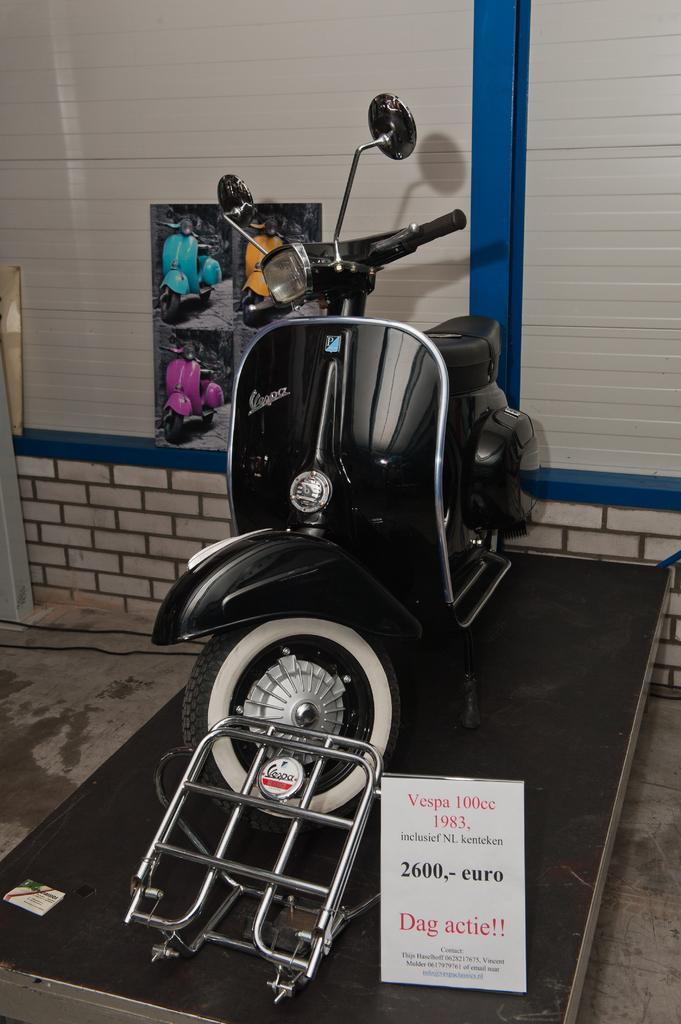Describe this image in one or two sentences. Here I can see a bike is placed on a metal surface. Along with the bike there are some metal rods and a board. On the board, I can see some text. In the background there is a wall to which a poster is attached. 